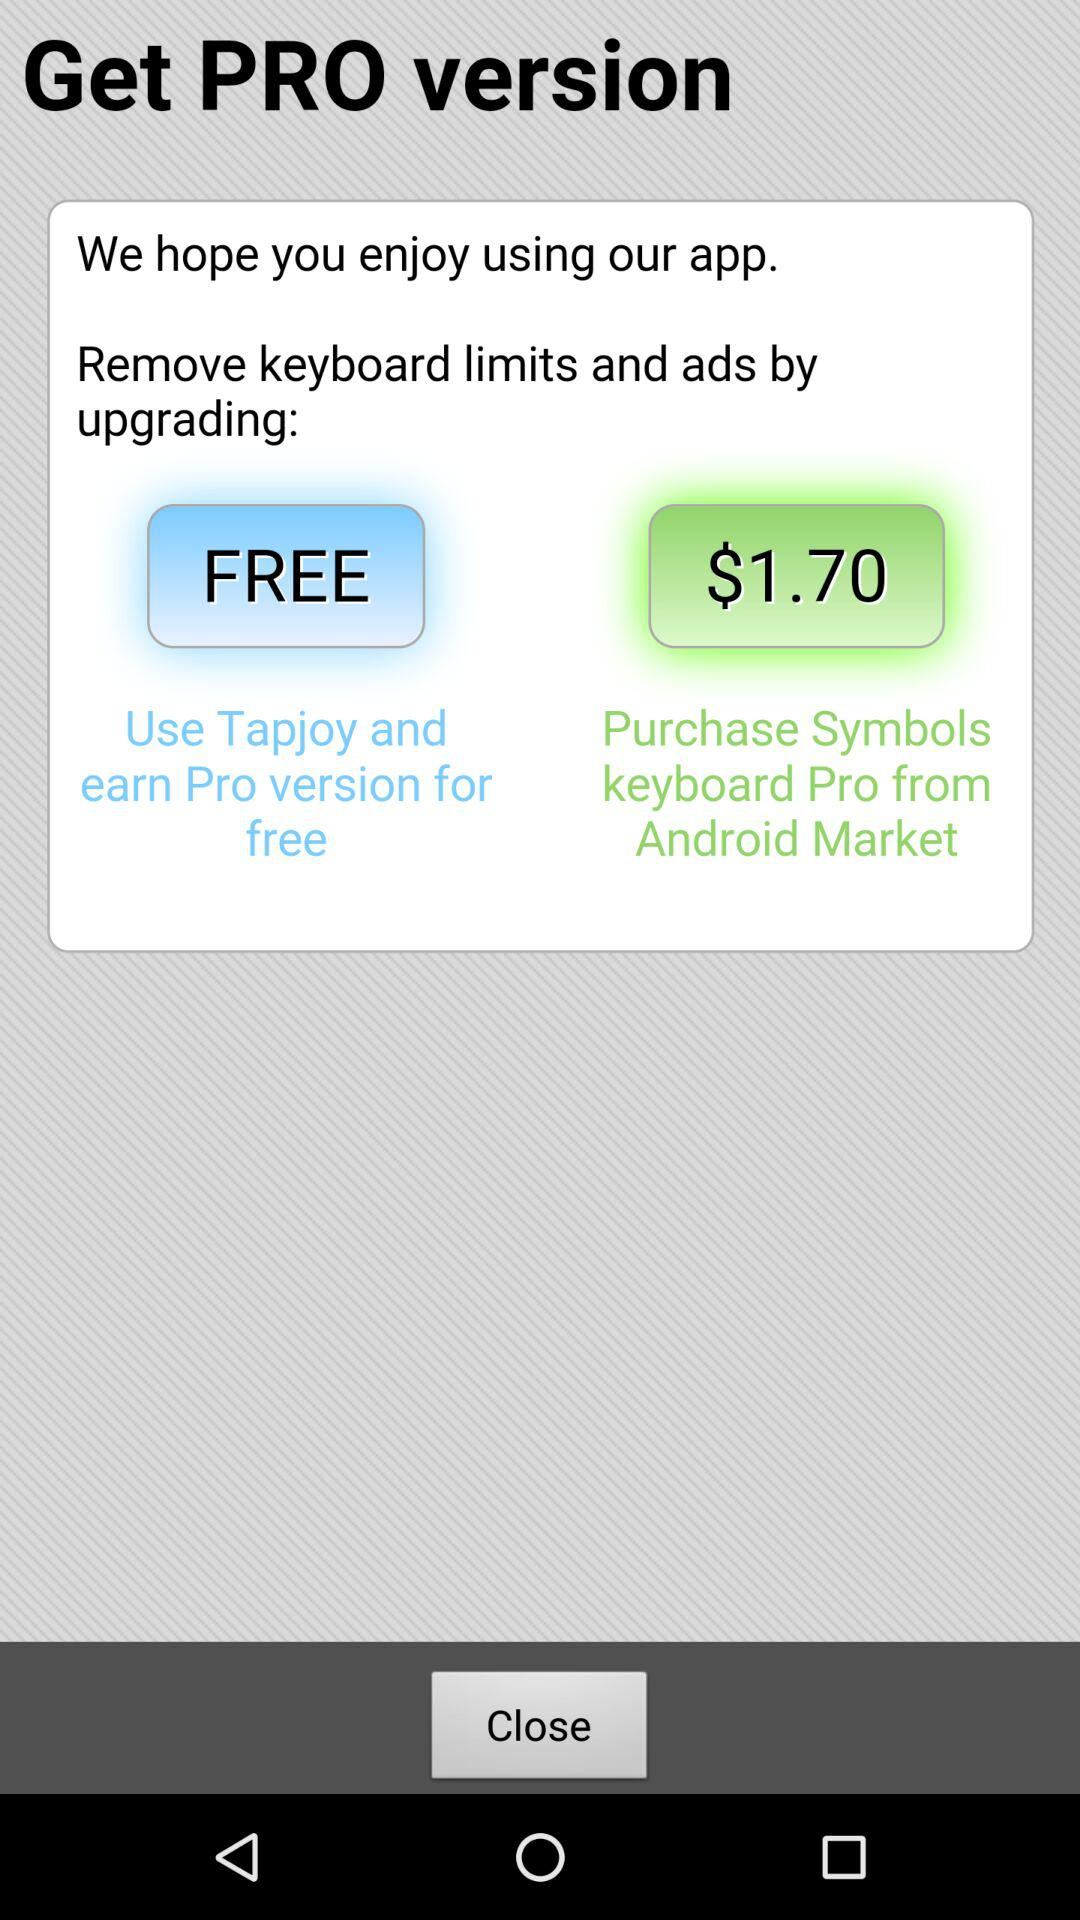What is the price for purchasing the Symbols keyboard Pro from the Android Market? The price for purchasing the Symbols keyboard Pro from the Android Market is $1.70. 